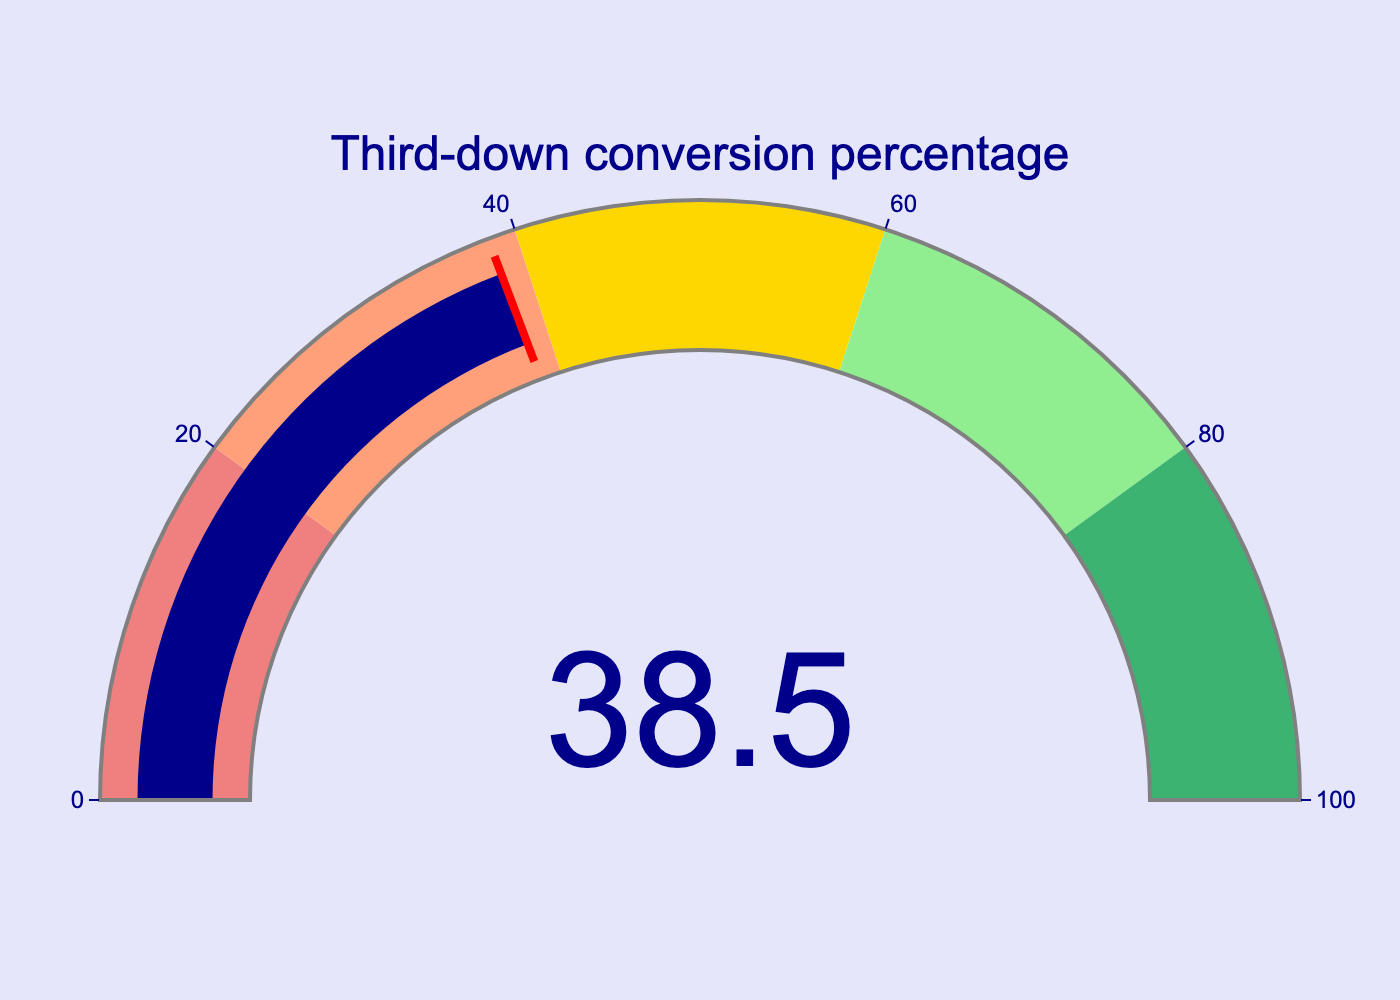What is the third-down conversion percentage for CSU Pueblo in 2023? The gauge chart shows the third-down conversion percentage as 38.5.
Answer: 38.5% What range is the third-down conversion percentage in? The gauge chart has several ranges indicated by different colors: 0-20 (lightcoral), 20-40 (lightsalmon), 40-60 (gold), 60-80 (lightgreen), and 80-100 (mediumseagreen). The value 38.5 falls within the 20-40 range (lightsalmon).
Answer: 20-40 range What color represents the current third-down conversion percentage? The gauge ranges are color-coded, and 38.5 falls within the 20-40 range, represented by the color lightsalmon.
Answer: lightsalmon How close is the third-down conversion percentage to reaching the 40% mark? The current value is 38.5. To reach the next mark, which is 40%, we need to find the difference: 40 - 38.5.
Answer: 1.5 Which threshold is more significant compared to the current third-down conversion percentage: 20% or 60%? The value is 38.5%, which is closer to 20% than to 60%. Therefore, 20% is more significant as it's nearer to the current value.
Answer: 20% Is the third-down conversion percentage above average given the gauge ranges? The ranges divide the spectrum into five parts, i.e., from 0 to 100. The midpoint average would be 50. The current percentage of 38.5 is below this average.
Answer: No, it's below average What range would represent a highly successful third-down conversion percentage based on the gauge chart? The gauge chart indicates successively better ranges, with the top range (80-100) represented by mediumseagreen. This would indicate a highly successful conversion rate.
Answer: 80-100 range If the third-down conversion percentage increased by 10%, what would be the new range? Adding 10% to 38.5 gives 38.5 + 10 = 48.5. This would place it in the 40-60 range, which is represented by the color gold.
Answer: 40-60 range What is the color representation for a third-down conversion percentage below 20%? The lowest range, 0-20, is represented by the color lightcoral as indicated on the gauge.
Answer: lightcoral 